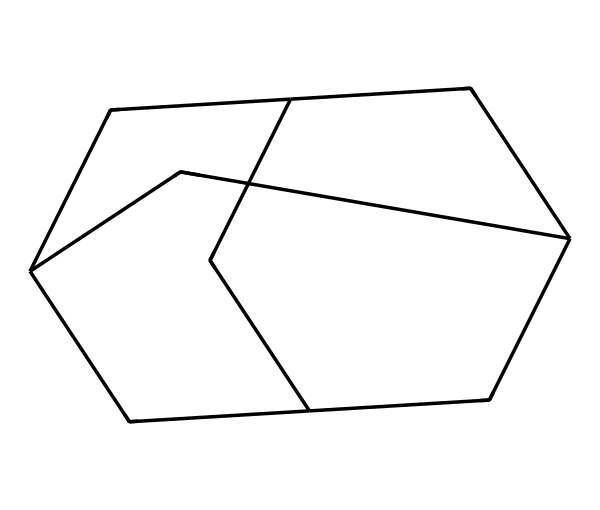What is the name of this chemical? The provided SMILES representation corresponds to adamantane, which is a well-known cage compound. By analyzing the structure, you can identify the specific arrangement of the carbon atoms that defines adamantane.
Answer: adamantane How many carbon atoms are present in this structure? The SMILES notation indicates the number of carbon atoms through the letter 'C' that represents carbon. There are 10 'C' in the SMILES representation, indicating that there are 10 carbon atoms in adamantane.
Answer: 10 What is the molecular formula of adamantane? To determine the molecular formula, count the number of carbon and hydrogen atoms from the structure. The molecular formula for adamantane, consisting of 10 carbon atoms and 16 hydrogen atoms, is C10H16.
Answer: C10H16 What type of structure does adamantane exhibit? Adamantane exhibits a cage-like structure, which is characteristic of certain hydrocarbons including cage compounds. This can be inferred from the 3-dimensional arrangement of carbon atoms that provides strength and stability.
Answer: cage-like How does the cage structure affect drug delivery? The cage-like structure of adamantane can encapsulate drug molecules, enhancing their stability and control over release, which can be beneficial in pharmaceutical applications. The structure allows for better interaction with biological membranes.
Answer: enhances stability What are potential applications of adamantane in pharmaceuticals? Due to its unique structure, adamantane is used in drug delivery systems and as a scaffold for developing antiviral and anticancer agents, where the stable cage structure can aid in drug efficacy.
Answer: drug delivery 